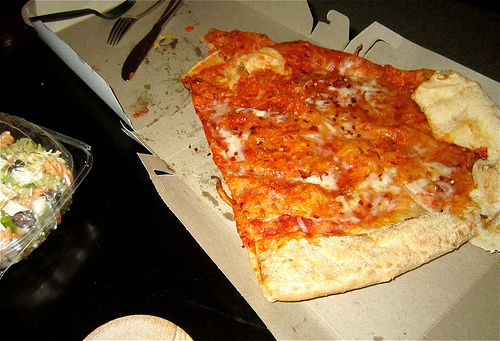Is there anything else on the table besides the food? Aside from the pizza slice and the salad, there is a white disposable fork, a crumpled napkin, and some crumbs on the table, indicating a recent dining experience. 